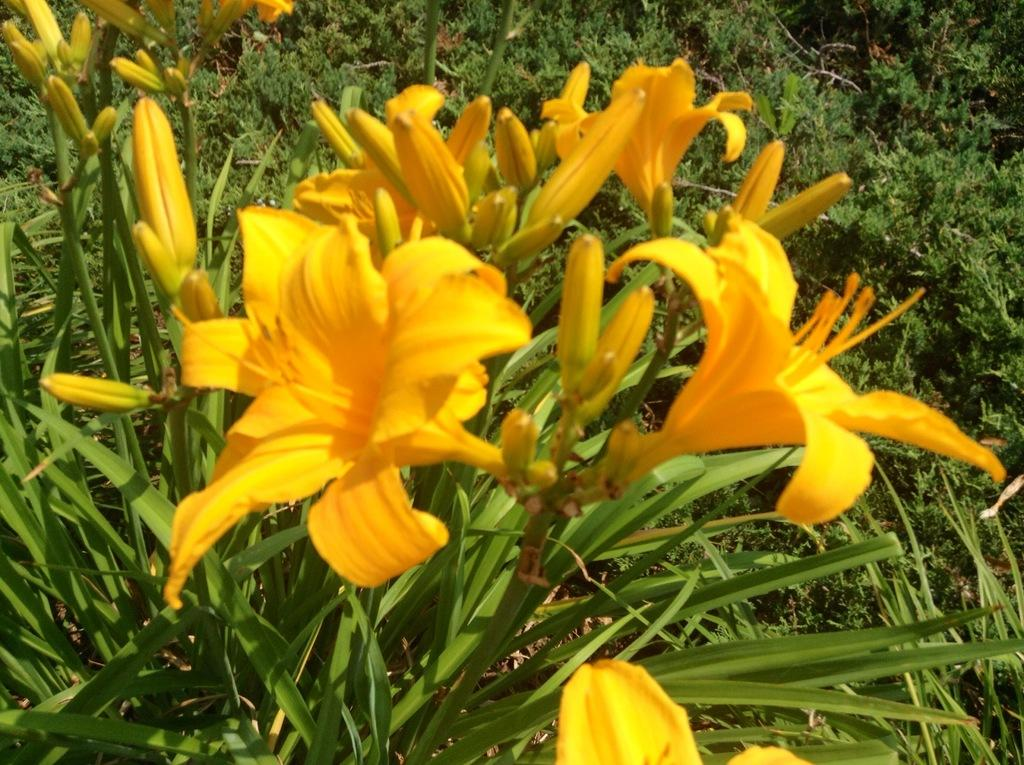What type of plant is visible in the image? There is a plant with flowers in the image. How is the plant positioned in relation to the other elements in the image? The plant is in front of the other elements in the image. What type of vegetation is present on the surface at the bottom of the image? There is grass on the surface at the bottom of the image. What type of wheel can be seen attached to the plant in the image? There is no wheel present in the image, and the plant is not attached to any wheel. 